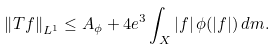Convert formula to latex. <formula><loc_0><loc_0><loc_500><loc_500>\left \| T f \right \| _ { L ^ { 1 } } \leq A _ { \phi } + 4 e ^ { 3 } \int _ { X } | f | \, \phi ( | f | ) \, d m .</formula> 